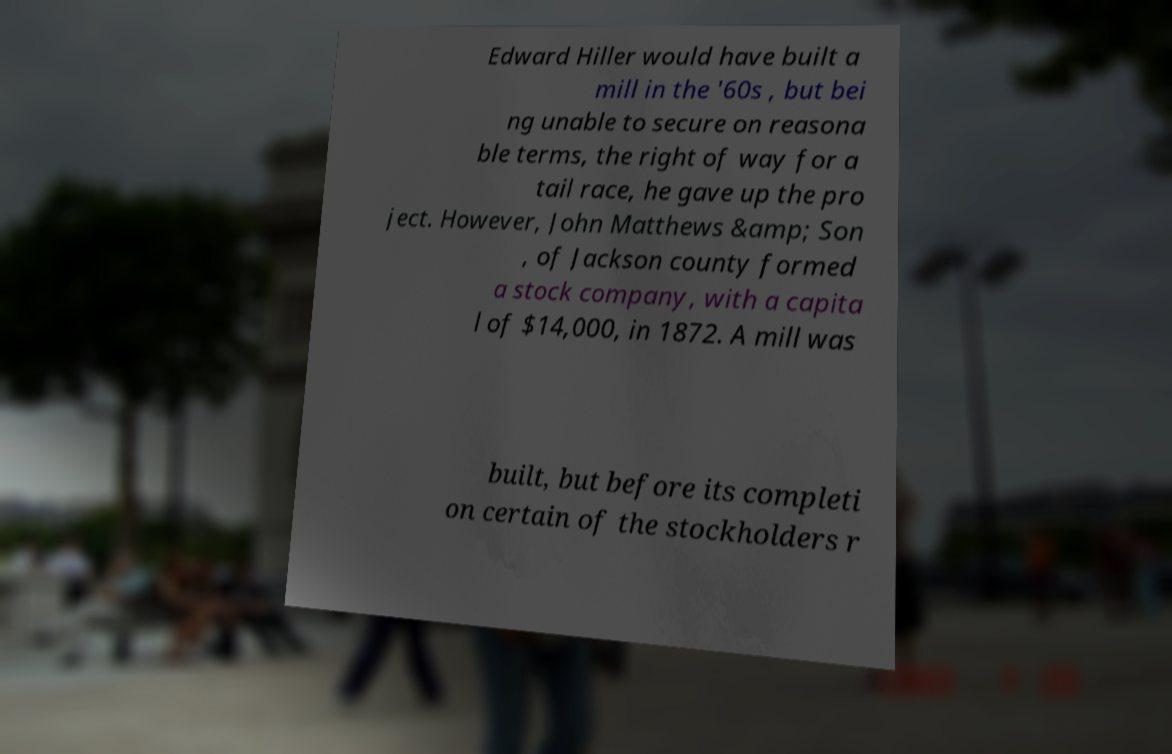Can you read and provide the text displayed in the image?This photo seems to have some interesting text. Can you extract and type it out for me? Edward Hiller would have built a mill in the '60s , but bei ng unable to secure on reasona ble terms, the right of way for a tail race, he gave up the pro ject. However, John Matthews &amp; Son , of Jackson county formed a stock company, with a capita l of $14,000, in 1872. A mill was built, but before its completi on certain of the stockholders r 